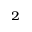<formula> <loc_0><loc_0><loc_500><loc_500>^ { 2 }</formula> 